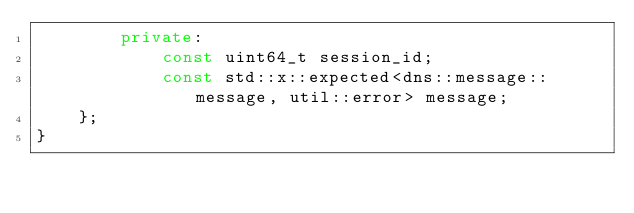Convert code to text. <code><loc_0><loc_0><loc_500><loc_500><_C++_>        private:
            const uint64_t session_id;
            const std::x::expected<dns::message::message, util::error> message;
    };
}
</code> 